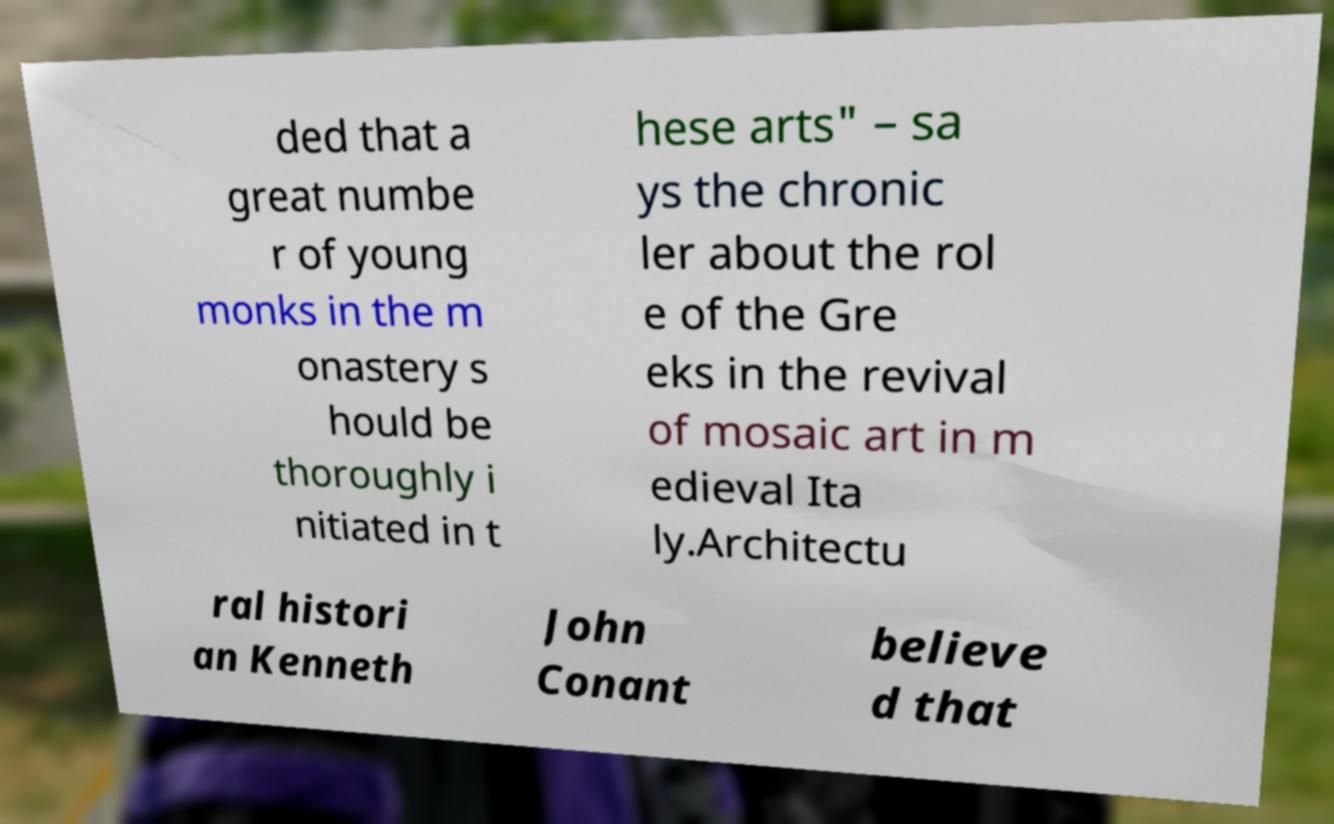What messages or text are displayed in this image? I need them in a readable, typed format. ded that a great numbe r of young monks in the m onastery s hould be thoroughly i nitiated in t hese arts" – sa ys the chronic ler about the rol e of the Gre eks in the revival of mosaic art in m edieval Ita ly.Architectu ral histori an Kenneth John Conant believe d that 